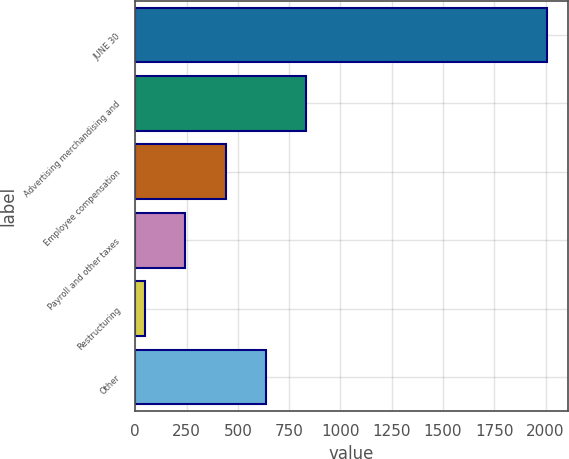Convert chart. <chart><loc_0><loc_0><loc_500><loc_500><bar_chart><fcel>JUNE 30<fcel>Advertising merchandising and<fcel>Employee compensation<fcel>Payroll and other taxes<fcel>Restructuring<fcel>Other<nl><fcel>2009<fcel>832.52<fcel>440.36<fcel>244.28<fcel>48.2<fcel>636.44<nl></chart> 